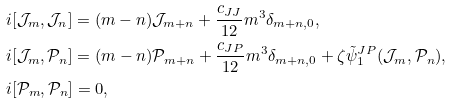Convert formula to latex. <formula><loc_0><loc_0><loc_500><loc_500>& i [ \mathcal { J } _ { m } , \mathcal { J } _ { n } ] = ( m - n ) \mathcal { J } _ { m + n } + \frac { c _ { J J } } { 1 2 } m ^ { 3 } \delta _ { m + n , 0 } , \\ & i [ \mathcal { J } _ { m } , \mathcal { P } _ { n } ] = ( m - n ) \mathcal { P } _ { m + n } + \frac { c _ { J P } } { 1 2 } m ^ { 3 } \delta _ { m + n , 0 } + \zeta \tilde { \psi } ^ { J P } _ { 1 } ( \mathcal { J } _ { m } , \mathcal { P } _ { n } ) , \\ & i [ \mathcal { P } _ { m } , \mathcal { P } _ { n } ] = 0 ,</formula> 